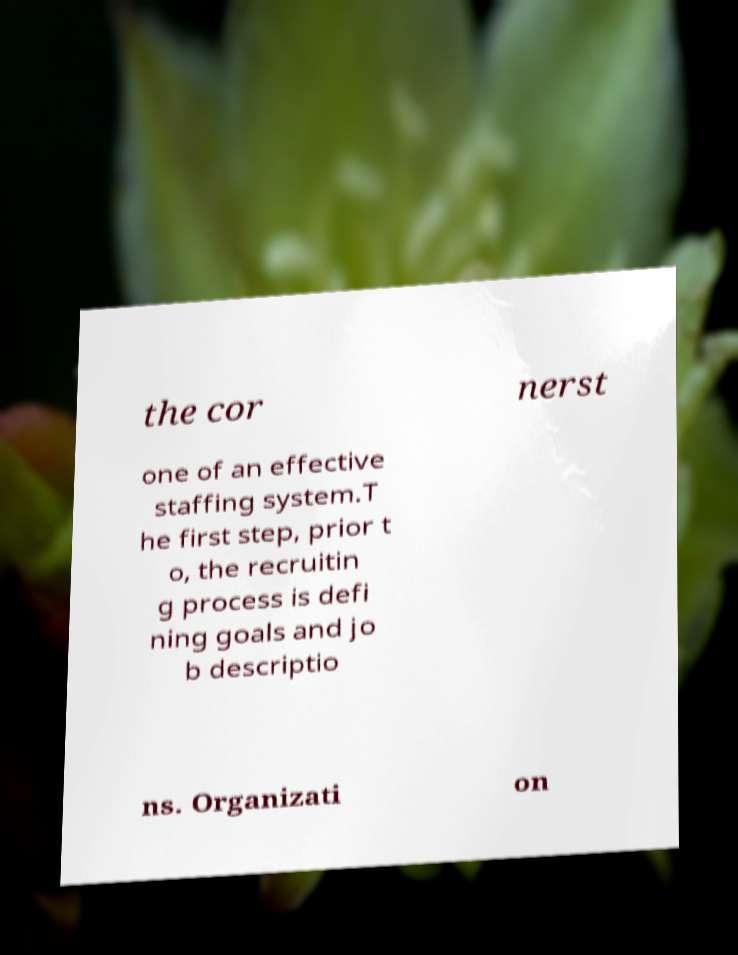Please identify and transcribe the text found in this image. the cor nerst one of an effective staffing system.T he first step, prior t o, the recruitin g process is defi ning goals and jo b descriptio ns. Organizati on 